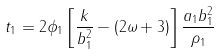Convert formula to latex. <formula><loc_0><loc_0><loc_500><loc_500>t _ { 1 } = 2 \phi _ { 1 } \left [ \frac { k } { b _ { 1 } ^ { 2 } } - ( 2 \omega + 3 ) \right ] \frac { a _ { 1 } b _ { 1 } ^ { 2 } } { \rho _ { 1 } }</formula> 